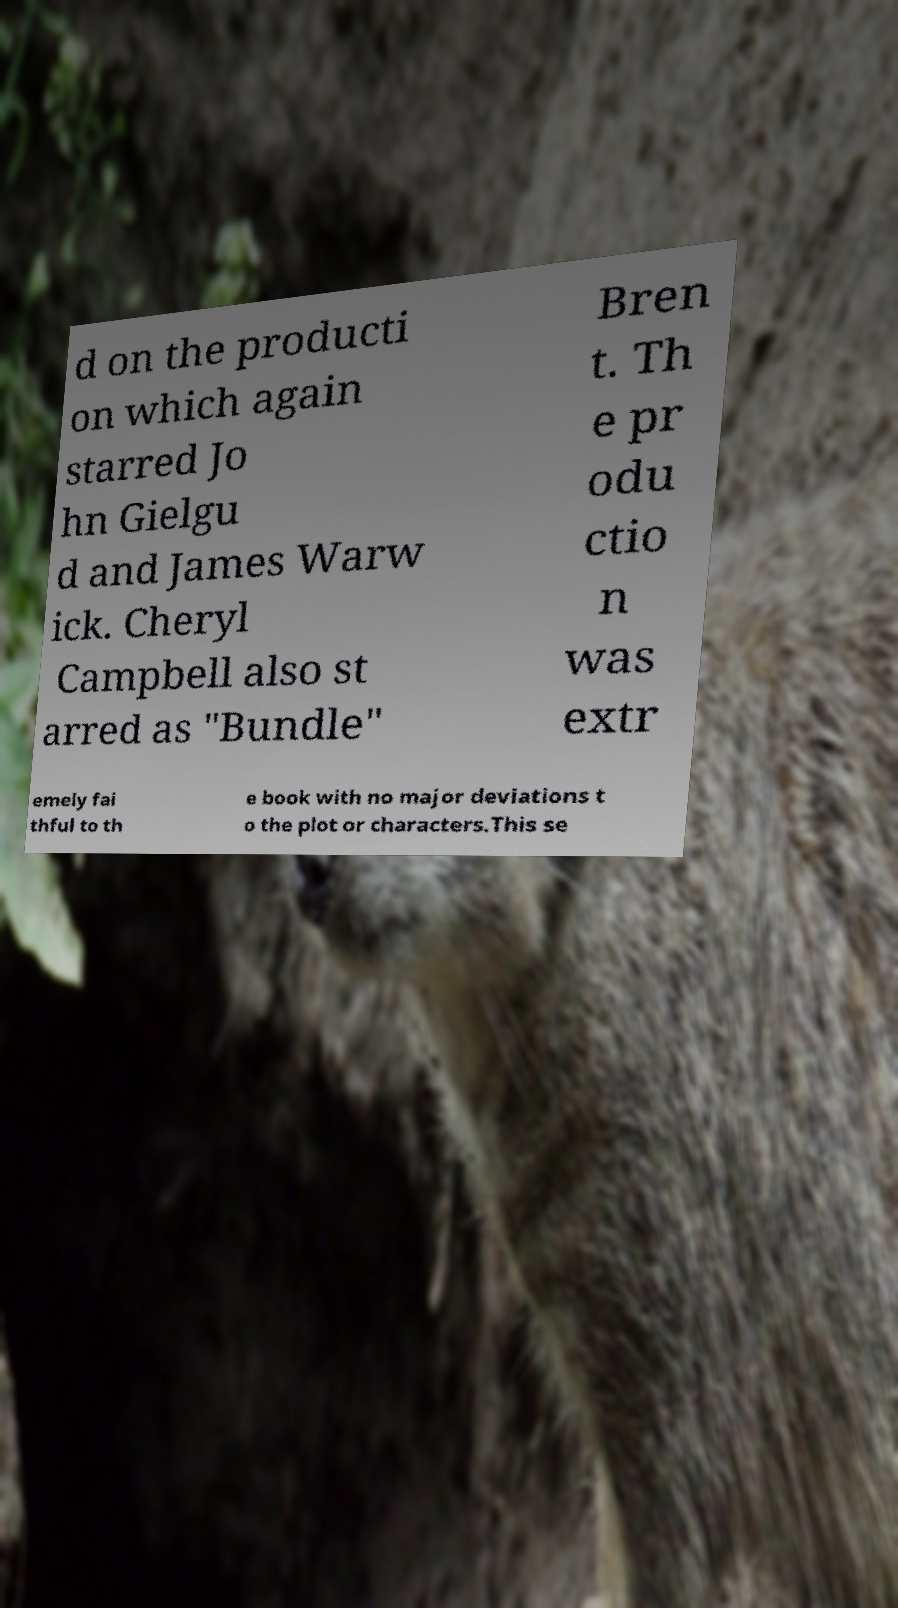For documentation purposes, I need the text within this image transcribed. Could you provide that? d on the producti on which again starred Jo hn Gielgu d and James Warw ick. Cheryl Campbell also st arred as "Bundle" Bren t. Th e pr odu ctio n was extr emely fai thful to th e book with no major deviations t o the plot or characters.This se 